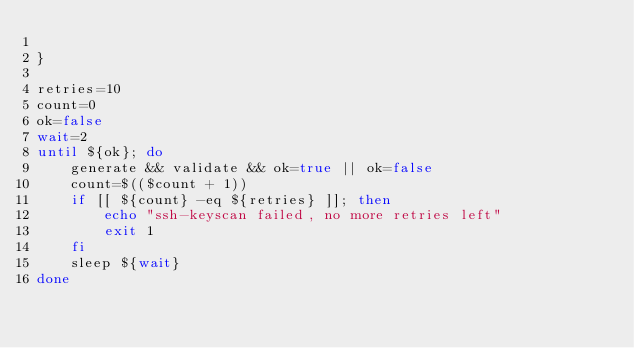<code> <loc_0><loc_0><loc_500><loc_500><_Bash_>
}

retries=10
count=0
ok=false
wait=2
until ${ok}; do
    generate && validate && ok=true || ok=false
    count=$(($count + 1))
    if [[ ${count} -eq ${retries} ]]; then
        echo "ssh-keyscan failed, no more retries left"
        exit 1
    fi
    sleep ${wait}
done
</code> 